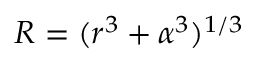<formula> <loc_0><loc_0><loc_500><loc_500>R = ( r ^ { 3 } + \alpha ^ { 3 } ) ^ { 1 / 3 }</formula> 